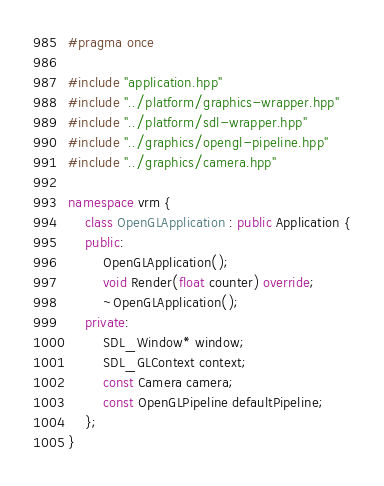<code> <loc_0><loc_0><loc_500><loc_500><_C++_>#pragma once

#include "application.hpp"
#include "../platform/graphics-wrapper.hpp"
#include "../platform/sdl-wrapper.hpp"
#include "../graphics/opengl-pipeline.hpp"
#include "../graphics/camera.hpp"

namespace vrm {
    class OpenGLApplication : public Application {
    public:
        OpenGLApplication();
        void Render(float counter) override;
        ~OpenGLApplication();
    private:
        SDL_Window* window;
        SDL_GLContext context;
        const Camera camera;
        const OpenGLPipeline defaultPipeline;
    };
}</code> 